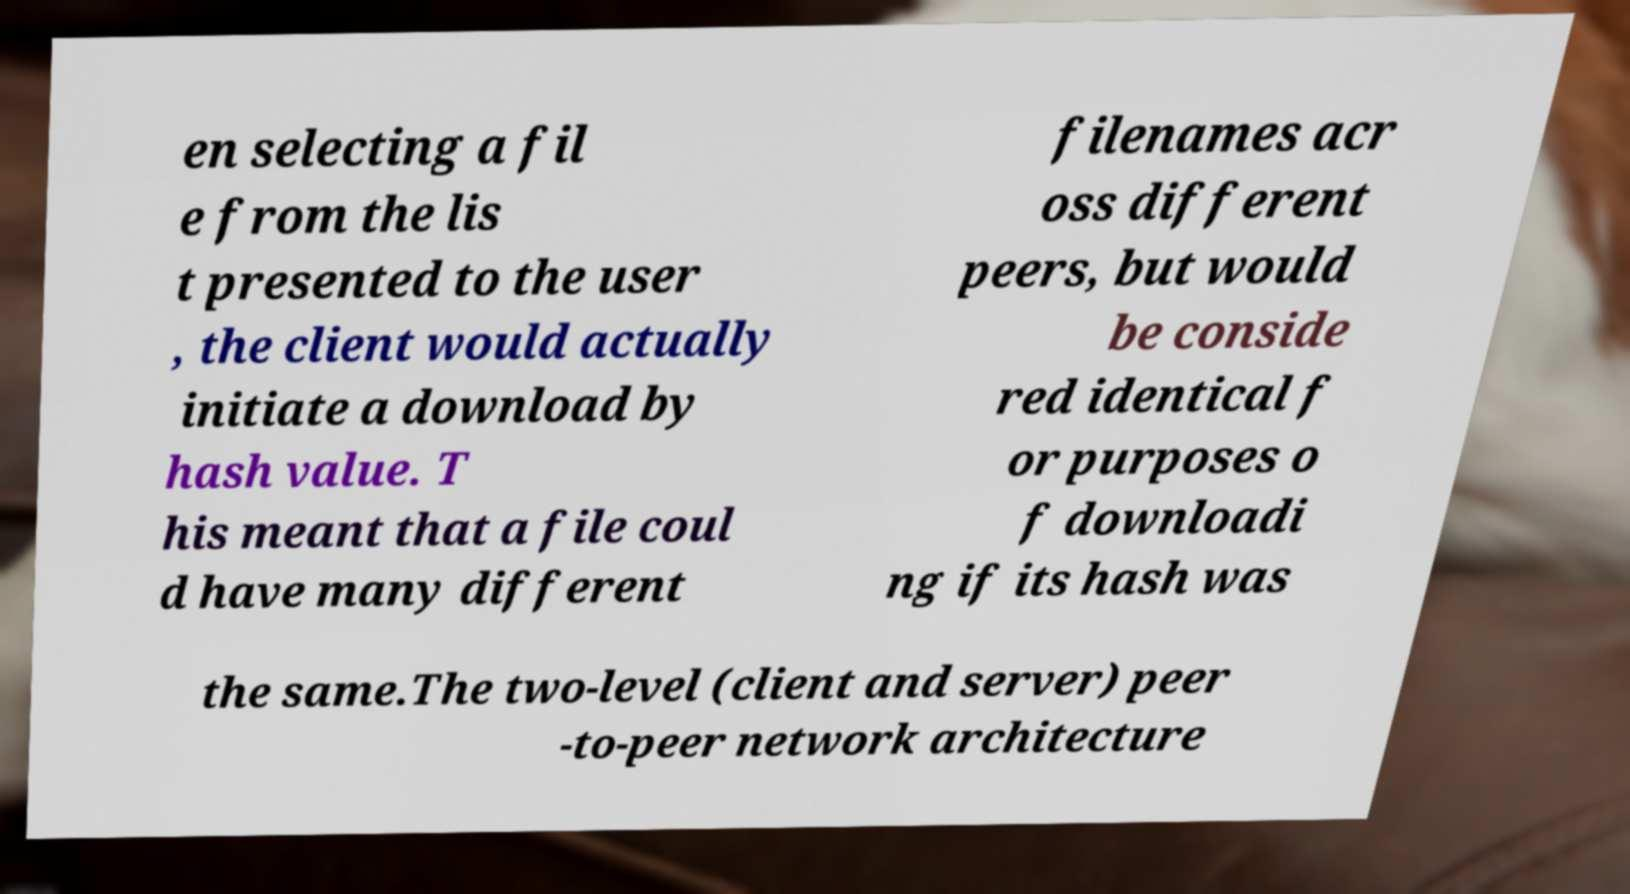What messages or text are displayed in this image? I need them in a readable, typed format. en selecting a fil e from the lis t presented to the user , the client would actually initiate a download by hash value. T his meant that a file coul d have many different filenames acr oss different peers, but would be conside red identical f or purposes o f downloadi ng if its hash was the same.The two-level (client and server) peer -to-peer network architecture 